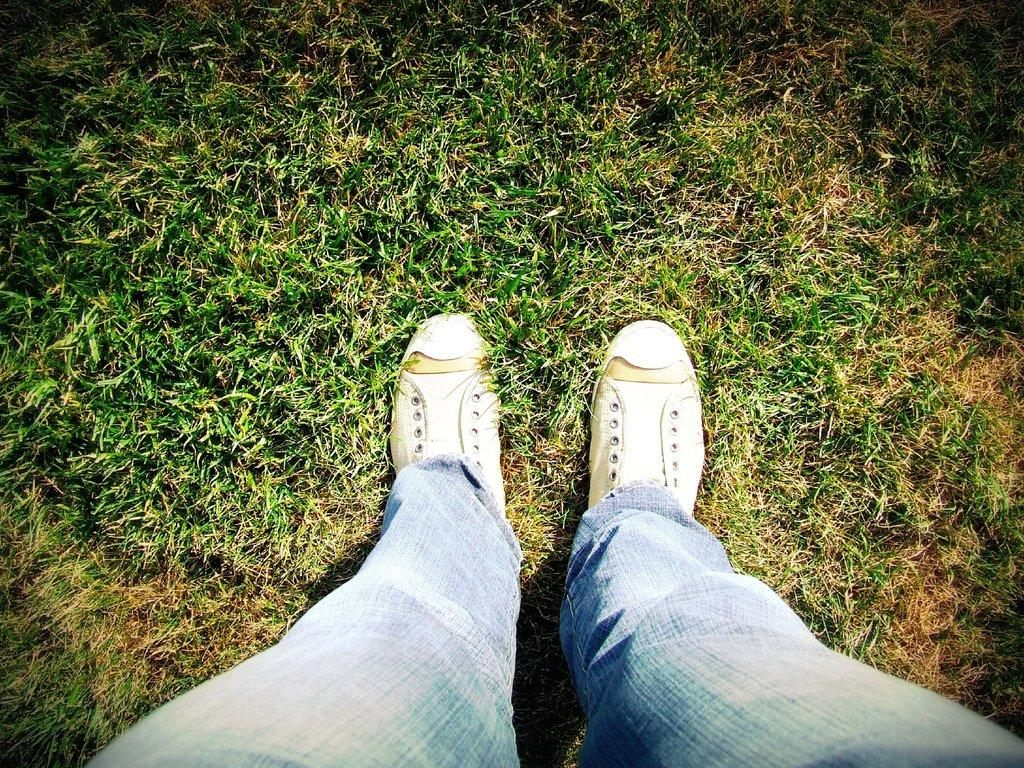What part of a person can be seen in the image? There are legs of a person visible in the image. What type of footwear is the person wearing? The person is wearing shoes. Where are the legs located in the image? The legs are on the grass. What type of voice can be heard coming from the person's back in the image? There is no voice or sound present in the image, as it only shows the legs of a person on the grass. 